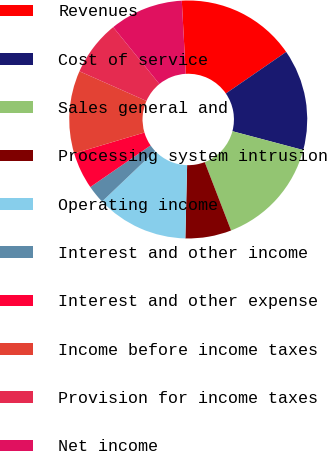Convert chart to OTSL. <chart><loc_0><loc_0><loc_500><loc_500><pie_chart><fcel>Revenues<fcel>Cost of service<fcel>Sales general and<fcel>Processing system intrusion<fcel>Operating income<fcel>Interest and other income<fcel>Interest and other expense<fcel>Income before income taxes<fcel>Provision for income taxes<fcel>Net income<nl><fcel>16.25%<fcel>13.75%<fcel>15.0%<fcel>6.25%<fcel>12.5%<fcel>2.5%<fcel>5.0%<fcel>11.25%<fcel>7.5%<fcel>10.0%<nl></chart> 